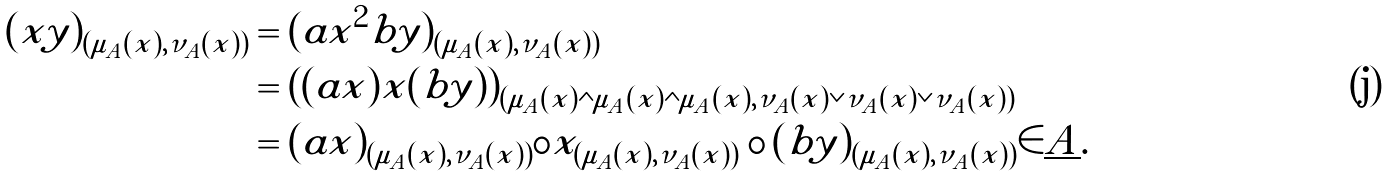Convert formula to latex. <formula><loc_0><loc_0><loc_500><loc_500>( x y ) _ { ( \mu _ { A } ( x ) , \nu _ { A } ( x ) ) } & = ( a x ^ { 2 } b y ) _ { ( \mu _ { A } ( x ) , \nu _ { A } ( x ) ) } \\ & = ( ( a x ) x ( b y ) ) _ { ( \mu _ { A } ( x ) \wedge \mu _ { A } ( x ) \wedge \mu _ { A } ( x ) , \nu _ { A } ( x ) \vee \nu _ { A } ( x ) \vee \nu _ { A } ( x ) ) } \\ & = ( a x ) _ { ( \mu _ { A } ( x ) , \nu _ { A } ( x ) ) } \circ x _ { ( \mu _ { A } ( x ) , \nu _ { A } ( x ) ) } \circ ( b y ) _ { ( \mu _ { A } ( x ) , \nu _ { A } ( x ) ) } \in \underline { A } .</formula> 